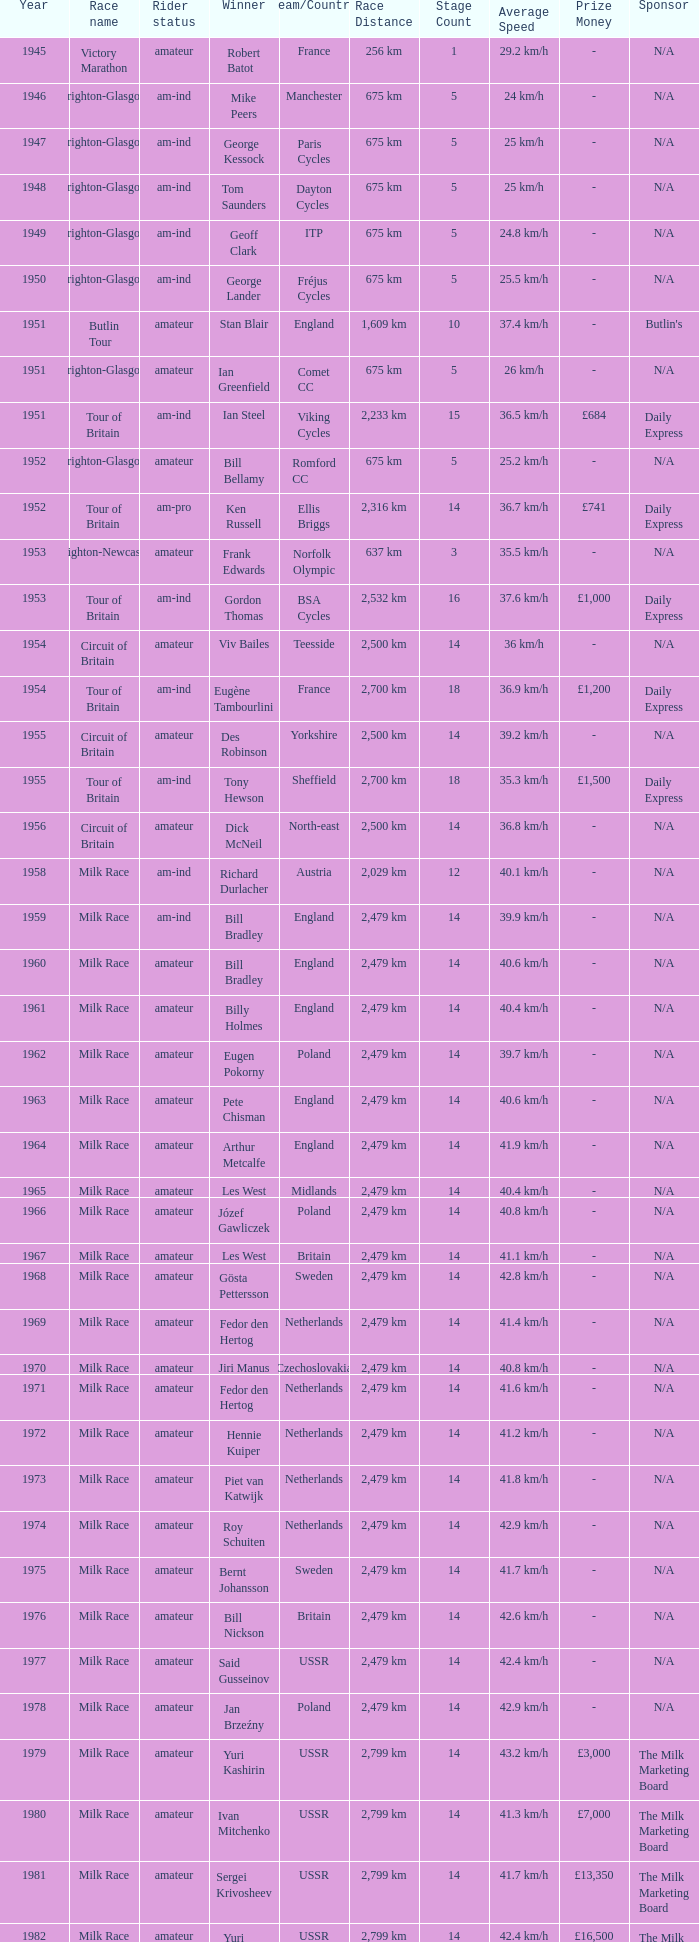What ream played later than 1958 in the kellogg's tour? ANC, Fagor, Z-Peugeot, Weinnmann-SMM, Motorola, Motorola, Motorola, Lampre. 